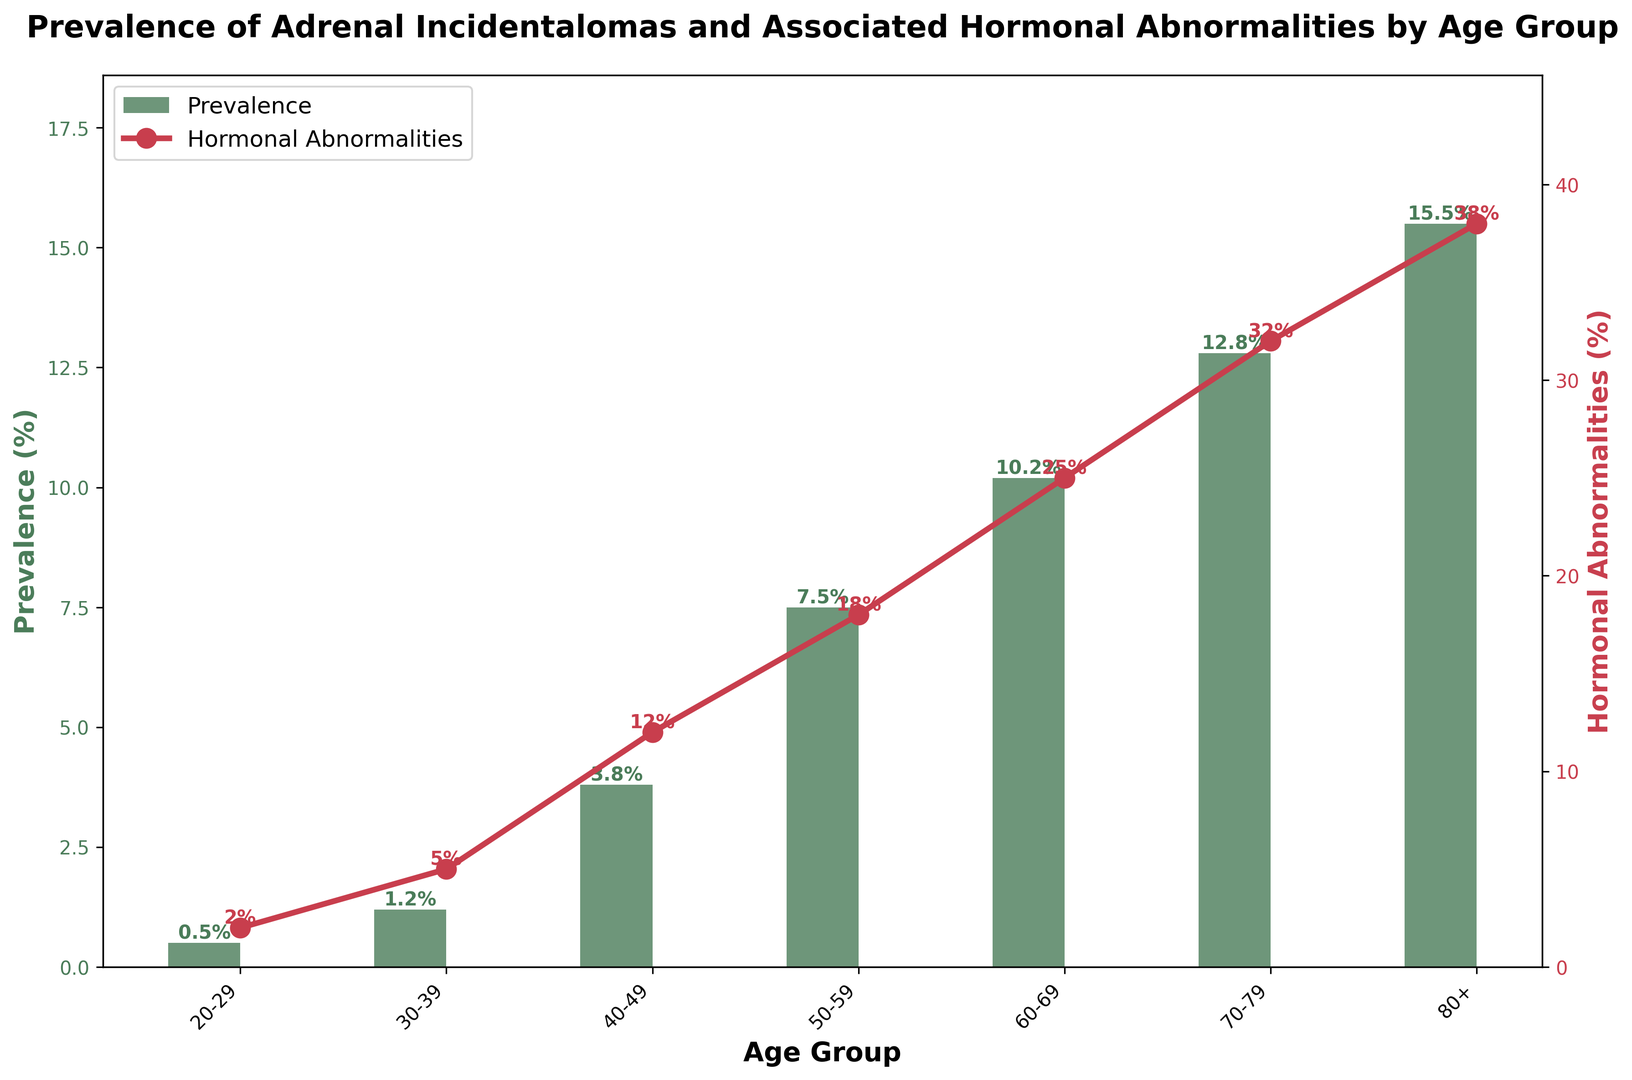Which age group has the highest prevalence of adrenal incidentalomas? By looking at the height of the green bars in the chart, the 80+ age group has the highest prevalence percentage.
Answer: 80+ What is the prevalence percentage of adrenal incidentalomas in the 50-59 age group? The height of the green bar for the 50-59 age group reaches 7.5%.
Answer: 7.5% How does the prevalence of adrenal incidentalomas in the 30-39 age group compare to the 70-79 age group? The green bar for the 30-39 age group is shorter compared to the 70-79 age group. Specifically, 1.2% versus 12.8%.
Answer: 1.2% vs 12.8% What is the total percentage increase in hormonal abnormalities from the 20-29 to the 80+ age group? The red line marker for hormonal abnormalities starts at 2% in the 20-29 age group and reaches 38% in the 80+ age group. The increase is 38% - 2% = 36%.
Answer: 36% Is there a consistent trend of increasing prevalence of adrenal incidentalomas with age? When looking at the green bars across the age groups from 20-29 to 80+, the heights continuously increase, indicating a consistent upward trend.
Answer: Yes What is the difference in hormonal abnormalities between the 40-49 and 60-69 age groups? The red line marker indicates 12% hormonal abnormalities in the 40-49 age group and 25% in the 60-69 age group. The difference is 25% - 12% = 13%.
Answer: 13% Which color represents the prevalence of adrenal incidentalomas? The green bars in the chart represent the prevalence.
Answer: Green During which age range does hormonal abnormality begin to exceed 20%? The red line marker crosses the 20% mark at the 60-69 age group.
Answer: 60-69 Calculate the average prevalence percentage across all age groups. Sum all prevalence values (0.5 + 1.2 + 3.8 + 7.5 + 10.2 + 12.8 + 15.5) = 51.5%. There are 7 age groups, so the average is 51.5% / 7 ≈ 7.36%.
Answer: 7.36% If the prevalence follows the same trend, what could be the likely prevalence for the 90+ age group? By observing the upward trend in green bars and extrapolating from 80+ group (15.5%), the prevalence might exceed 15.5%, potentially something around 17-18%.
Answer: ~17-18% 